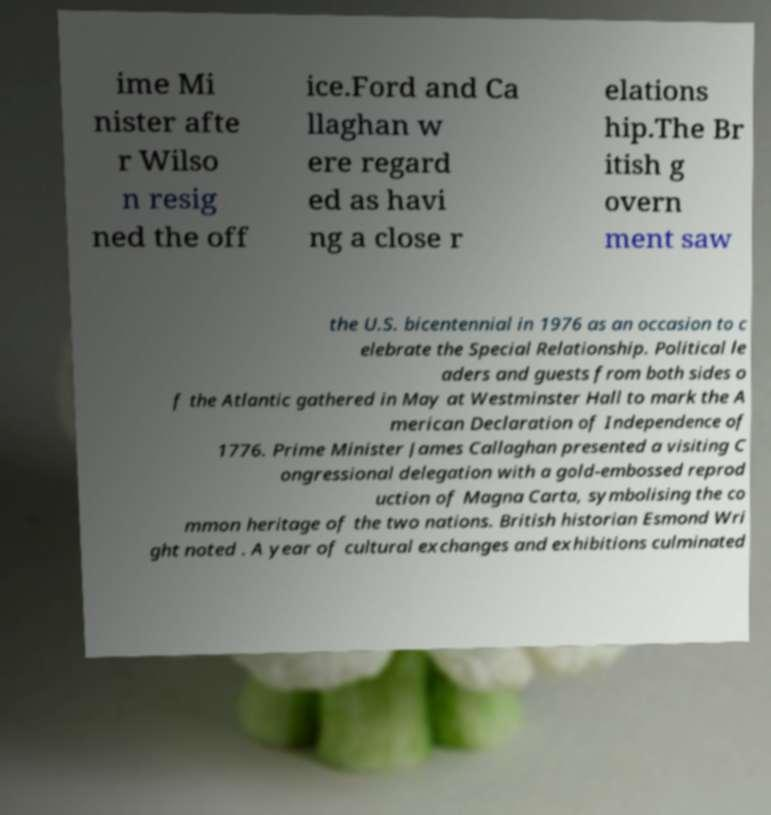What messages or text are displayed in this image? I need them in a readable, typed format. ime Mi nister afte r Wilso n resig ned the off ice.Ford and Ca llaghan w ere regard ed as havi ng a close r elations hip.The Br itish g overn ment saw the U.S. bicentennial in 1976 as an occasion to c elebrate the Special Relationship. Political le aders and guests from both sides o f the Atlantic gathered in May at Westminster Hall to mark the A merican Declaration of Independence of 1776. Prime Minister James Callaghan presented a visiting C ongressional delegation with a gold-embossed reprod uction of Magna Carta, symbolising the co mmon heritage of the two nations. British historian Esmond Wri ght noted . A year of cultural exchanges and exhibitions culminated 